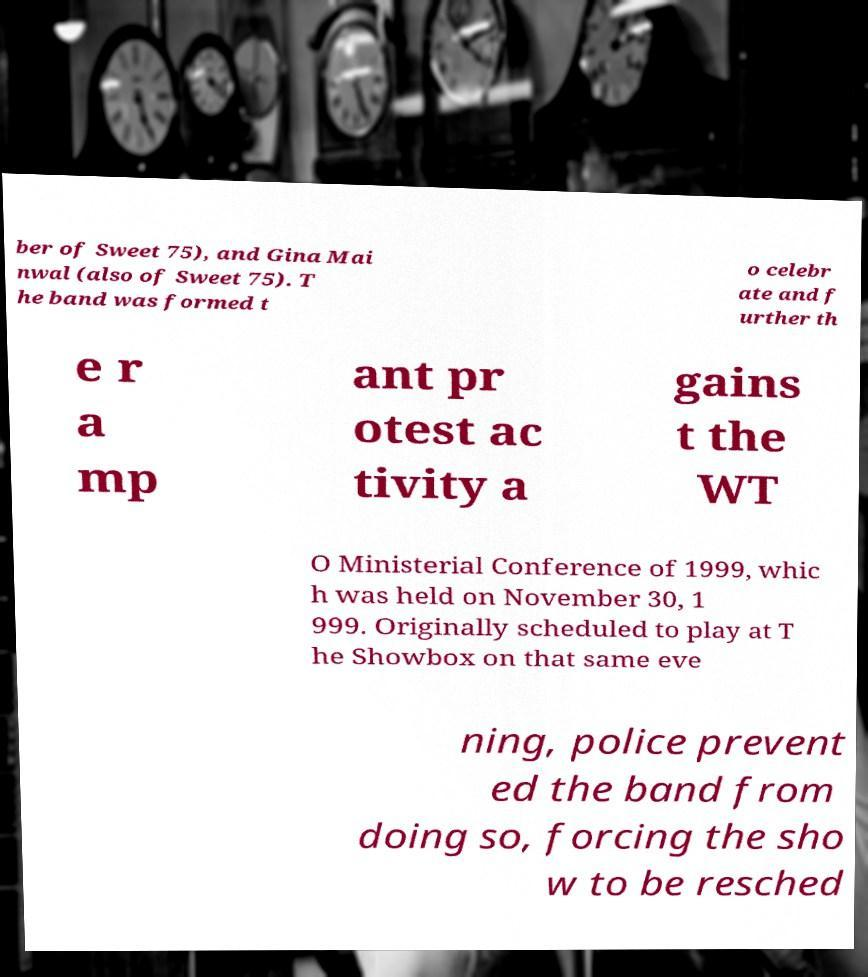What messages or text are displayed in this image? I need them in a readable, typed format. ber of Sweet 75), and Gina Mai nwal (also of Sweet 75). T he band was formed t o celebr ate and f urther th e r a mp ant pr otest ac tivity a gains t the WT O Ministerial Conference of 1999, whic h was held on November 30, 1 999. Originally scheduled to play at T he Showbox on that same eve ning, police prevent ed the band from doing so, forcing the sho w to be resched 